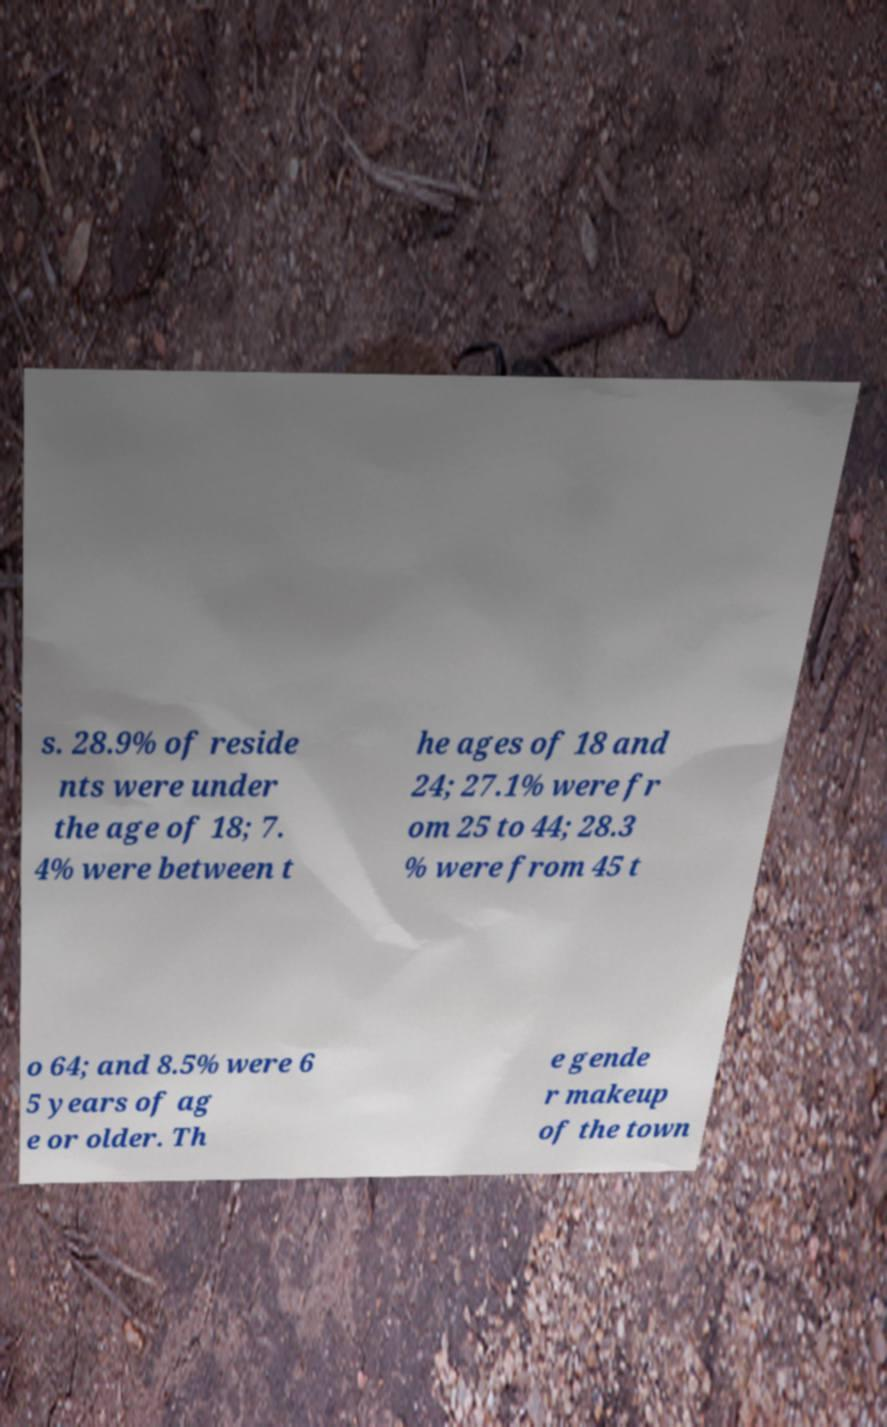Please identify and transcribe the text found in this image. s. 28.9% of reside nts were under the age of 18; 7. 4% were between t he ages of 18 and 24; 27.1% were fr om 25 to 44; 28.3 % were from 45 t o 64; and 8.5% were 6 5 years of ag e or older. Th e gende r makeup of the town 